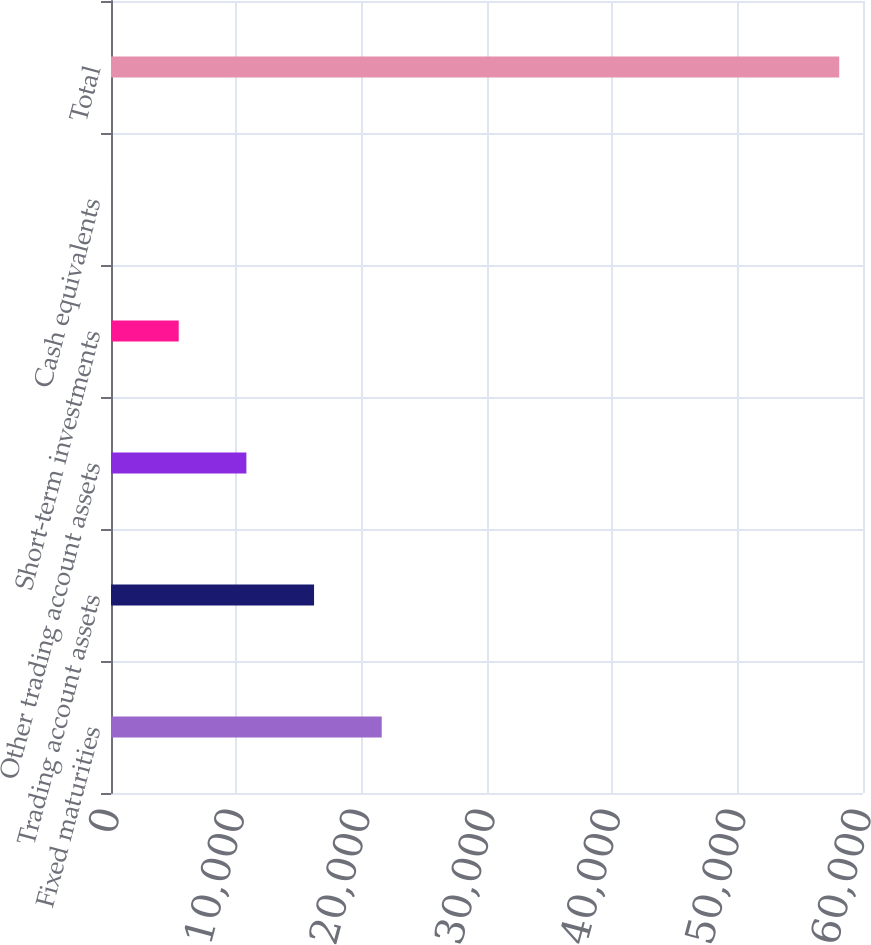<chart> <loc_0><loc_0><loc_500><loc_500><bar_chart><fcel>Fixed maturities<fcel>Trading account assets<fcel>Other trading account assets<fcel>Short-term investments<fcel>Cash equivalents<fcel>Total<nl><fcel>21601<fcel>16201.6<fcel>10802.3<fcel>5402.94<fcel>3.6<fcel>58102.3<nl></chart> 